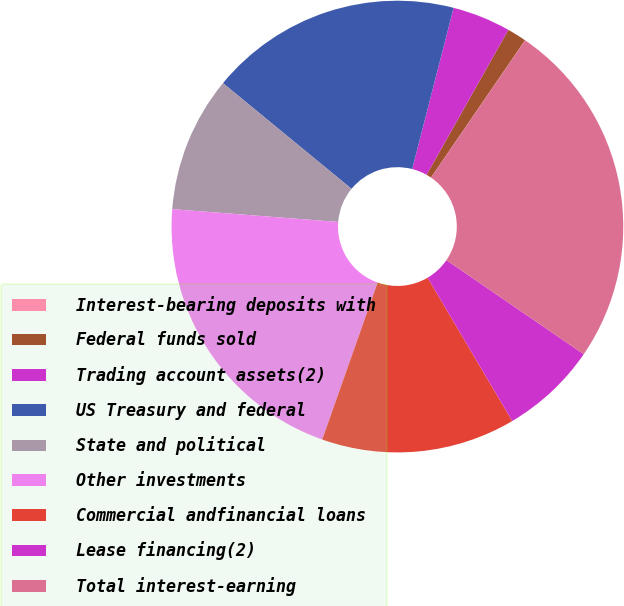Convert chart. <chart><loc_0><loc_0><loc_500><loc_500><pie_chart><fcel>Interest-bearing deposits with<fcel>Federal funds sold<fcel>Trading account assets(2)<fcel>US Treasury and federal<fcel>State and political<fcel>Other investments<fcel>Commercial andfinancial loans<fcel>Lease financing(2)<fcel>Total interest-earning<nl><fcel>0.01%<fcel>1.39%<fcel>4.17%<fcel>18.05%<fcel>9.72%<fcel>20.83%<fcel>13.89%<fcel>6.95%<fcel>24.99%<nl></chart> 